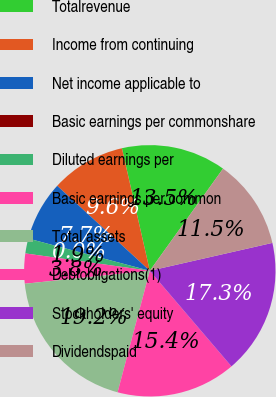Convert chart. <chart><loc_0><loc_0><loc_500><loc_500><pie_chart><fcel>Totalrevenue<fcel>Income from continuing<fcel>Net income applicable to<fcel>Basic earnings per commonshare<fcel>Diluted earnings per<fcel>Basic earnings per common<fcel>Total assets<fcel>Debtobligations(1)<fcel>Stockholders' equity<fcel>Dividendspaid<nl><fcel>13.46%<fcel>9.62%<fcel>7.69%<fcel>0.0%<fcel>1.92%<fcel>3.85%<fcel>19.23%<fcel>15.38%<fcel>17.31%<fcel>11.54%<nl></chart> 